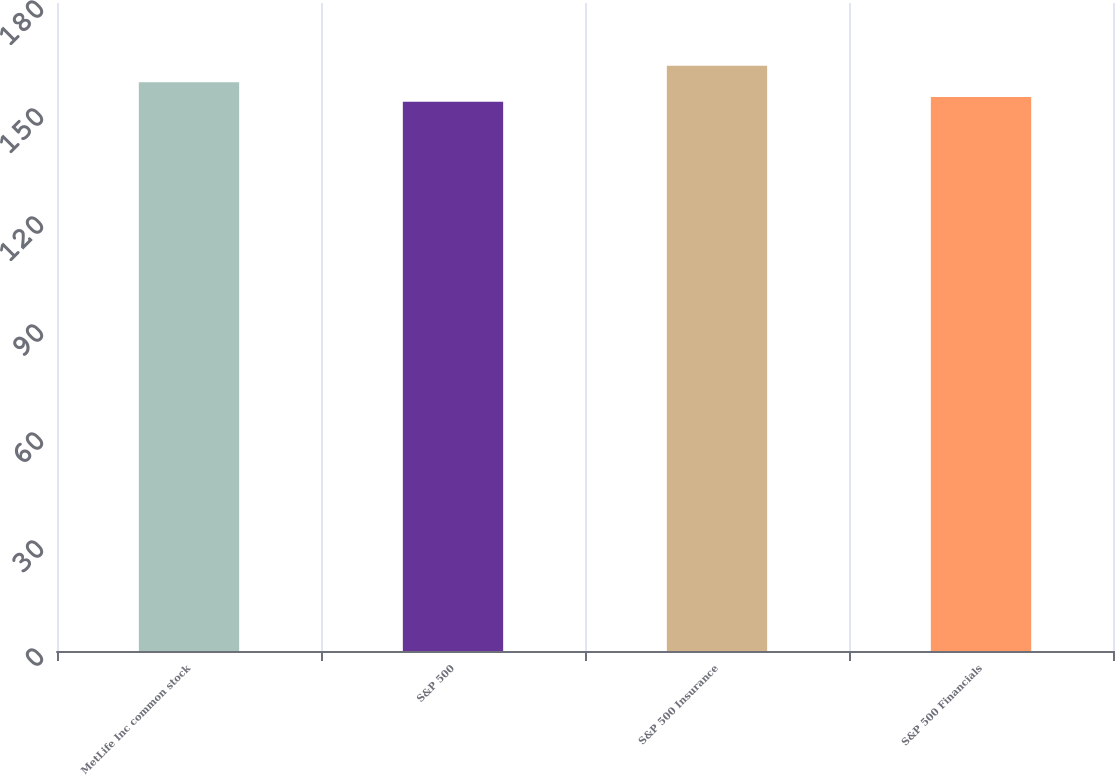<chart> <loc_0><loc_0><loc_500><loc_500><bar_chart><fcel>MetLife Inc common stock<fcel>S&P 500<fcel>S&P 500 Insurance<fcel>S&P 500 Financials<nl><fcel>157.96<fcel>152.59<fcel>162.56<fcel>153.86<nl></chart> 